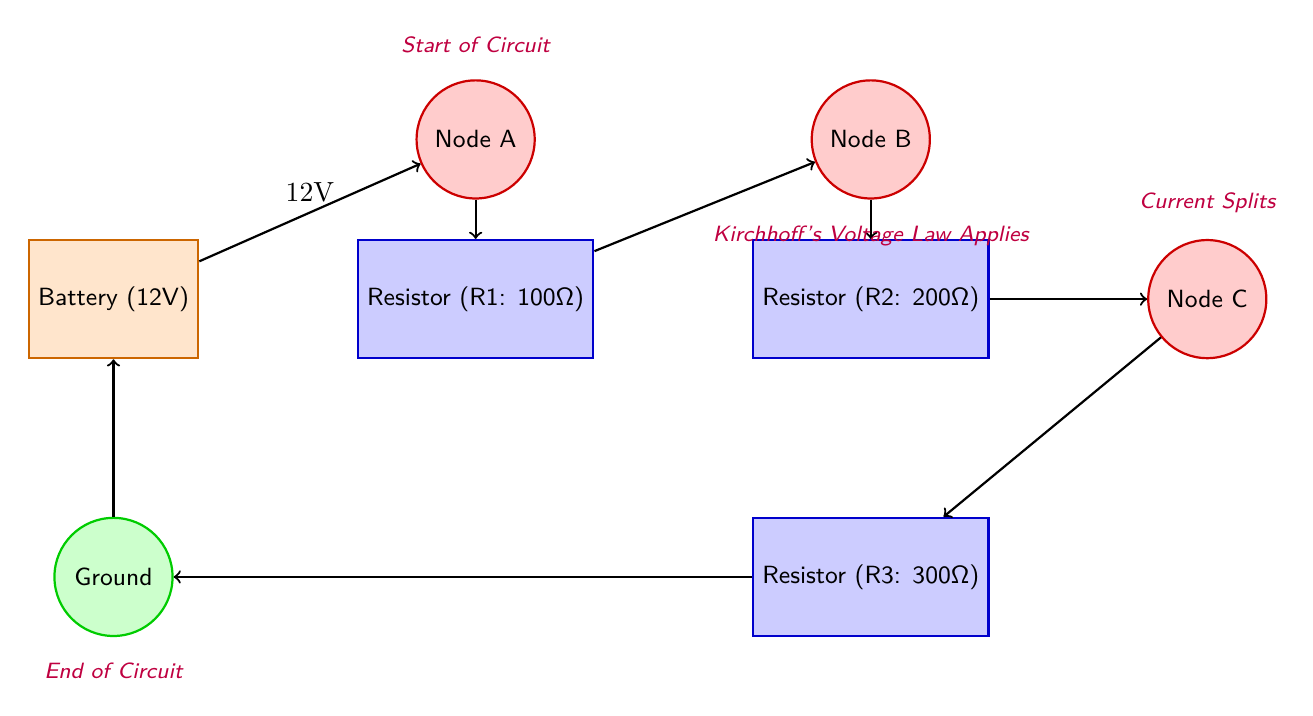What is the voltage of the battery? The voltage value is explicitly stated in the diagram next to the battery component. It indicates the electric potential provided by the battery in the circuit.
Answer: 12V How many resistors are in the circuit? By counting the individual resistor components shown in the diagram, we find three resistors labeled R1, R2, and R3.
Answer: 3 What is the resistance of Resistor 2? The value of Resistor 2 is given in the diagram as part of its label. This specifies the resistance value that it contributes to the circuit.
Answer: 200Ω Where does the current split according to the diagram? The diagram indicates that the current splits at Node B, where it encounters Resistor 2 and can be directed to Node C or flow through Resistor 3 below.
Answer: Node B What applies at Node B according to the annotations? The annotations in the diagram describe the application of a specific law at Node B, which is related to the voltage and current analysis in the circuit.
Answer: Kirchhoff's Voltage Law What is the resistance of Resistor 1? Resistor 1's value is provided within the component label in the diagram, detailing the resistance it offers to the electrical flow.
Answer: 100Ω What is the total resistance in series for R1 and R2? To find the total resistance of resistors in series, you sum their resistances. Thus, total resistance equals R1 (100Ω) + R2 (200Ω) = 300Ω.
Answer: 300Ω What is the role of the ground in this circuit? The ground provides a reference point for the circuit, establishing a common return path for current. It is noted as the final node in the circuit flow.
Answer: Ground At which node does the current enter after the battery? Based on the directional arrows in the diagram, the current flows directly from the battery into the first node, which is indicated as Node A.
Answer: Node A 